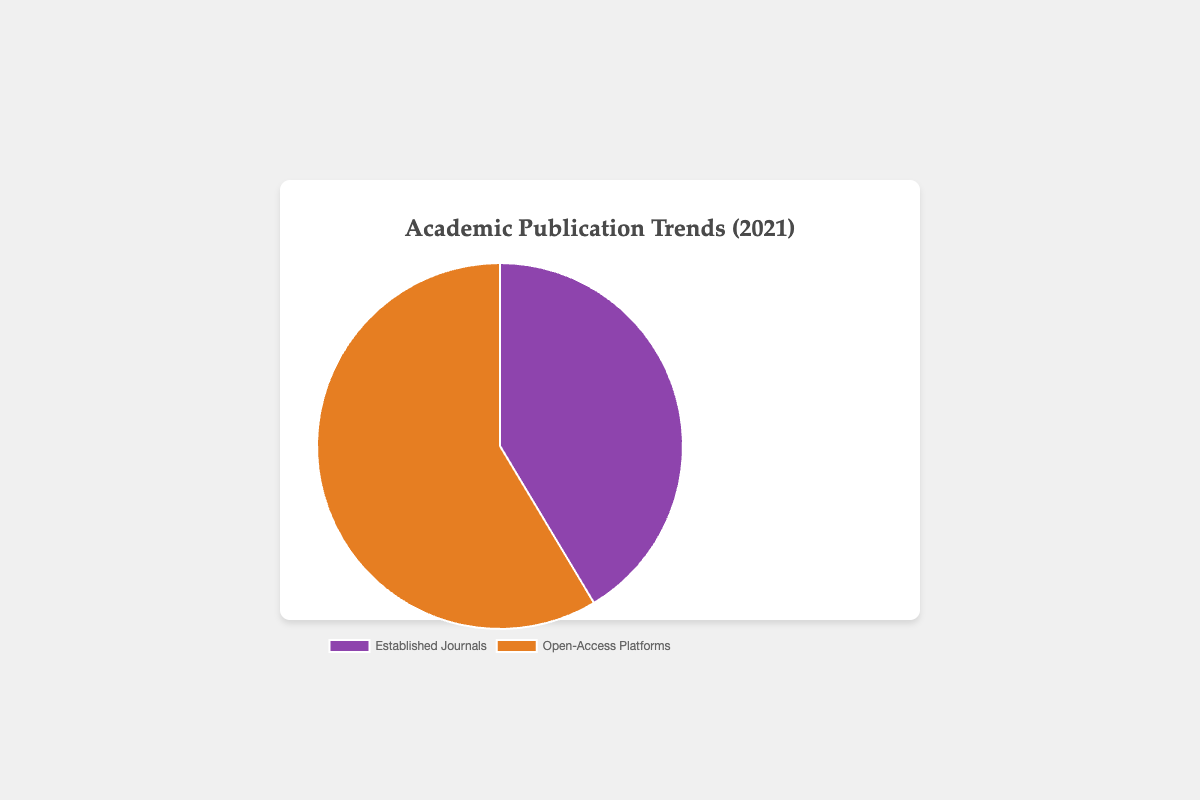What percentage of academic publications were from Open-Access Platforms in 2021? The pie chart shows the data distributions for both Established Journals and Open-Access Platforms. The Open-Access Platforms section's value is given as 6650. The overall value is the sum of Established Journals (4700) and Open-Access Platforms (6650), which equals 11350. The percentage for Open-Access Platforms is calculated as (6650 / 11350) * 100 ≈ 58.57%.
Answer: 58.57% How many more publications were there in Open-Access Platforms compared to Established Journals in 2021? The pie chart has the data for both categories: Established Journals with 4700 publications and Open-Access Platforms with 6650 publications. The difference is 6650 - 4700, which equals 1950.
Answer: 1950 Which category has a higher number of publications in 2021: Established Journals or Open-Access Platforms? By inspecting the pie chart, we observe that the segment representing Open-Access Platforms is larger than that for Established Journals. The values given are 6650 for Open-Access Platforms and 4700 for Established Journals; therefore, Open-Access Platforms have a higher number of publications.
Answer: Open-Access Platforms What is the total number of publications in 2021? According to the pie chart, Established Journals have 4700 publications and Open-Access Platforms have 6650 publications. The total sum is therefore 4700 + 6650, which equals 11350.
Answer: 11350 How does the distribution of publications between Established Journals and Open-Access Platforms in 2021 reflect on the visibility of open-access research? Using the pie chart, the Open-Access Platforms' publications (6650) are significantly more than those of Established Journals (4700). This suggests a growing trend and visibility preference towards open-access research platforms.
Answer: Open-Access research is more visible If the total number of publications increased by 10% in 2022 while maintaining the same distribution ratio, what would be the approximate number of publications for Established Journals in 2022? The total number of publications in 2021 is 11350. With a 10% increase, the new total is 11350 * 1.10 = 12485. The distribution ratio for Established Journals is 4700 / 11350 ≈ 0.414. For 2022, the approximate number of publications for Established Journals is 12485 * 0.414 ≈ 5166.
Answer: 5166 What is the difference in the percentage (to the nearest integer) between Established Journals and Open-Access Platforms in 2021? The percentage for Established Journals is (4700 / 11350) * 100 ≈ 41.43%, and for Open-Access Platforms, it is (6650 / 11350) * 100 ≈ 58.57%. The difference is roughly 58.57% - 41.43% = 17%.
Answer: 17% What conclusion can be drawn from the larger segment being orange in the pie chart? The orange segment in the pie chart represents Open-Access Platforms, which is visibly larger, indicating that Open-Access Platforms had more publications than Established Journals in 2021.
Answer: Open-Access Platforms had more publications 